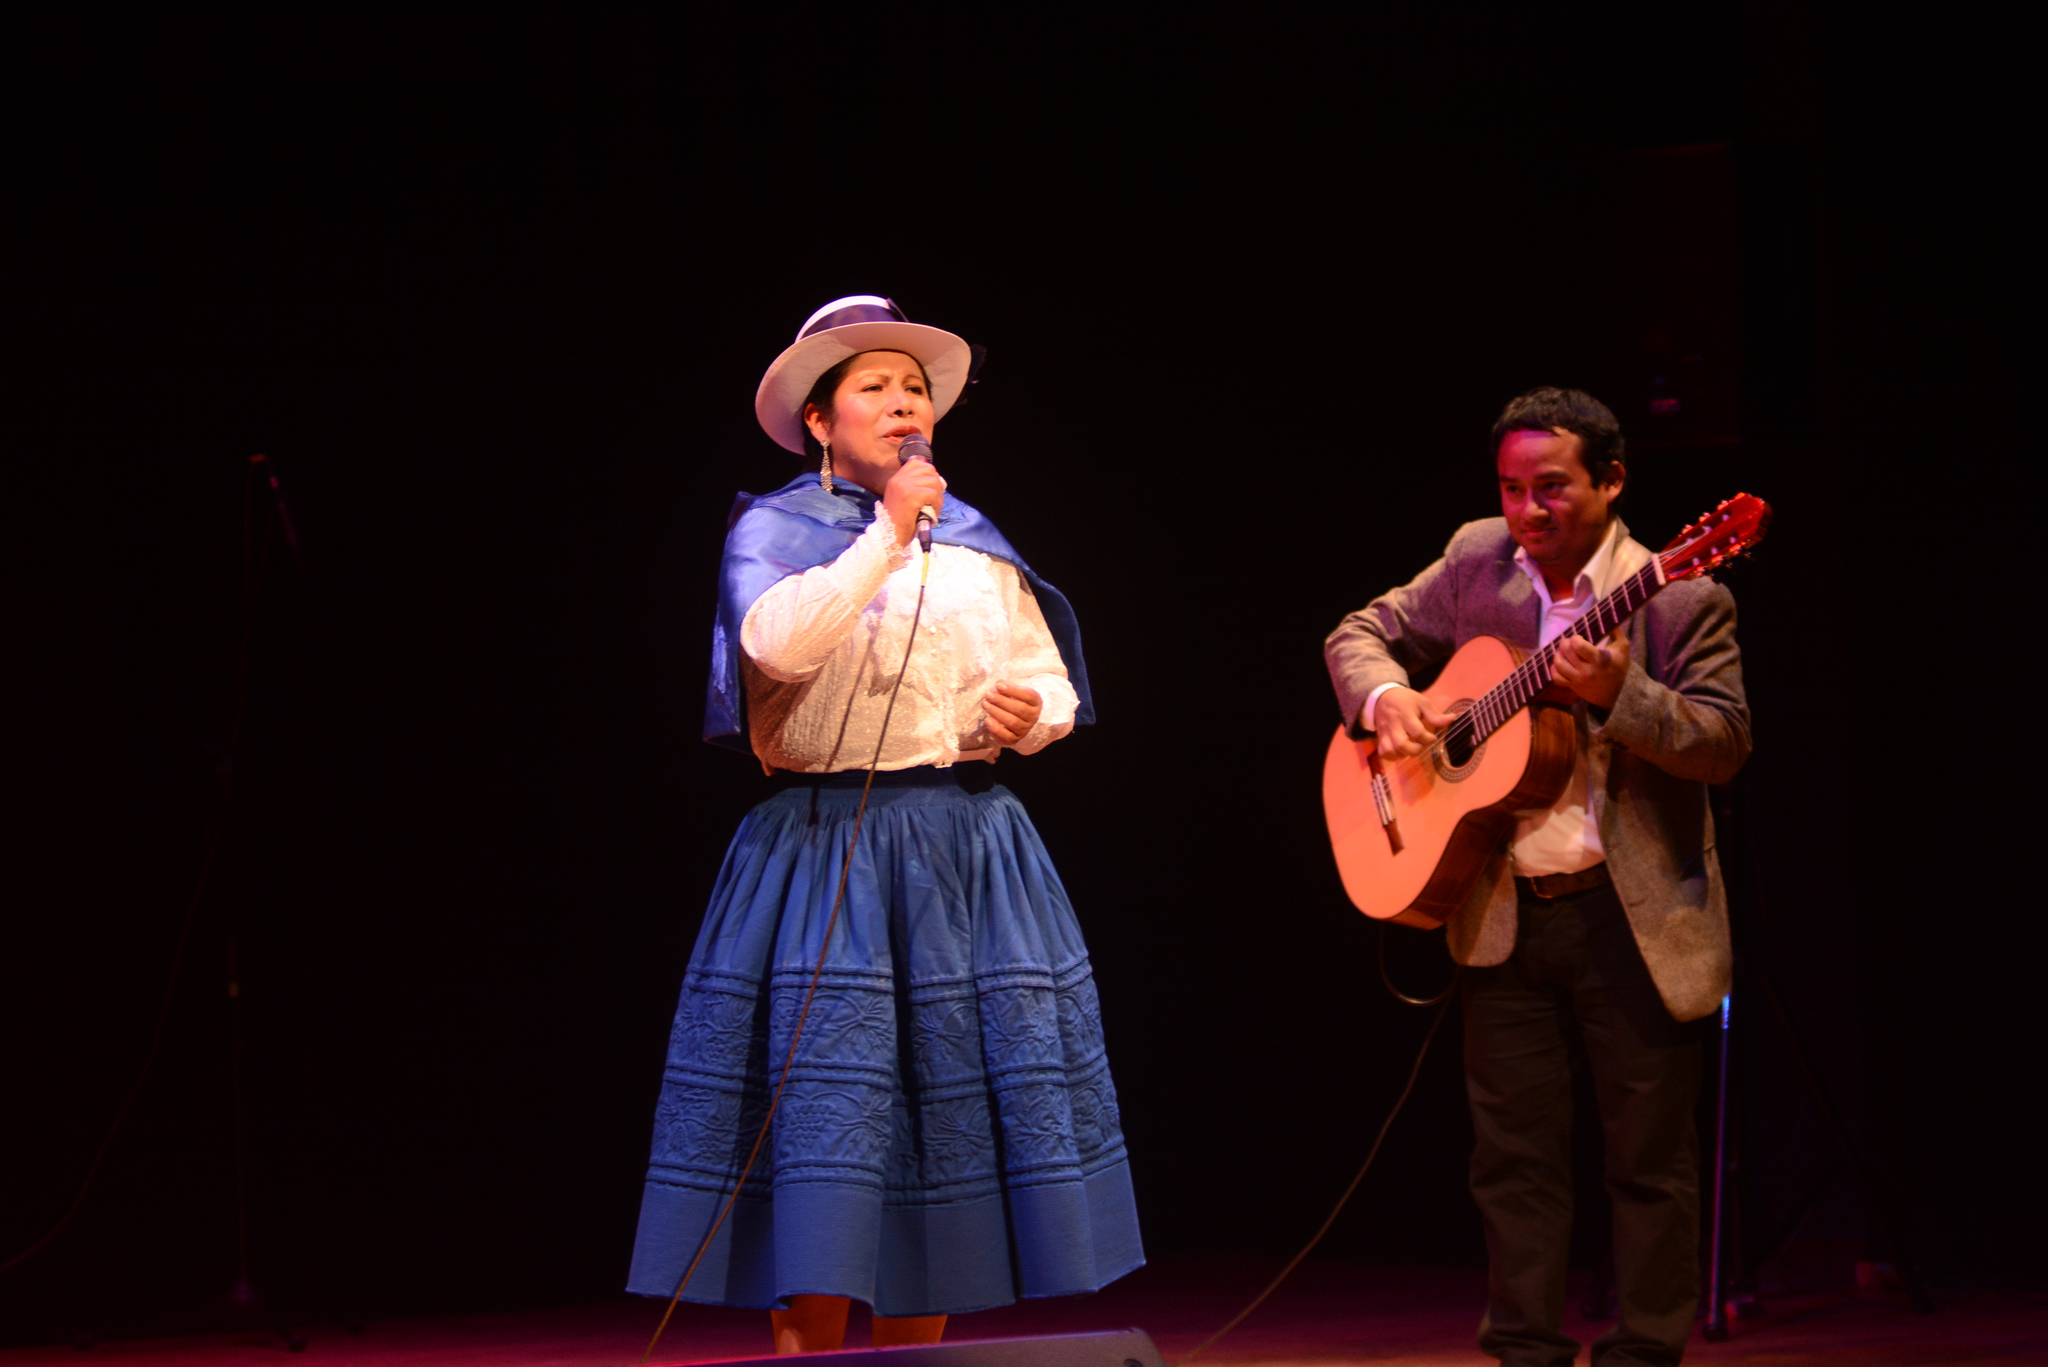Please provide a concise description of this image. in the center we can see woman holding microphone. And on the right we can see one man holding guitar. 